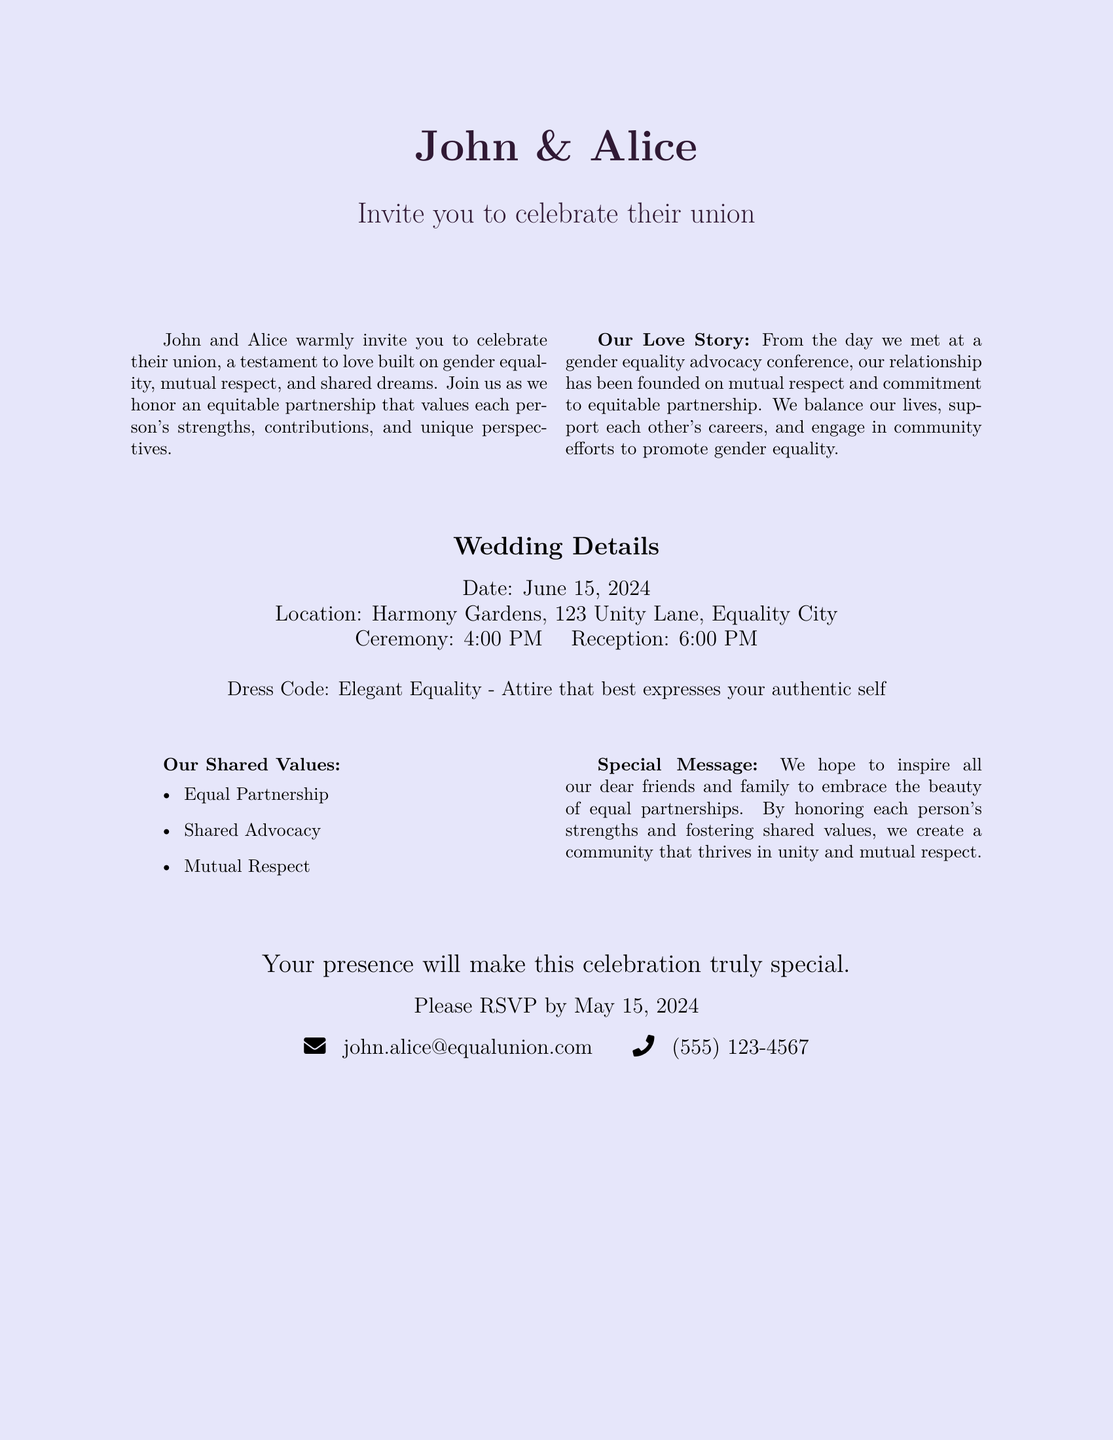What are the names of the couple? The names of the couple are mentioned prominently at the top of the invitation as "John & Alice."
Answer: John & Alice What is the date of the wedding? The date of the wedding is indicated in the wedding details section of the document.
Answer: June 15, 2024 Where is the wedding ceremony taking place? The location of the wedding ceremony is specified in the wedding details section.
Answer: Harmony Gardens, 123 Unity Lane, Equality City What time does the ceremony start? The start time for the ceremony is listed in the wedding details section.
Answer: 4:00 PM What is the dress code for the wedding? The dress code is described in the wedding details section as a special theme.
Answer: Elegant Equality What is a key value highlighted in the couple's love story? The love story section refers to several shared values focused on their relationship.
Answer: Equal Partnership Why do John and Alice want to inspire their friends and family? The special message section explains their desire to inspire others regarding partnerships.
Answer: Embrace the beauty of equal partnerships At what time does the reception begin? The reception time is mentioned in the wedding details section, indicating when it follows the ceremony.
Answer: 6:00 PM What type of event is being celebrated? The nature of the event is indicated in the opening statement of the invitation.
Answer: Their union 